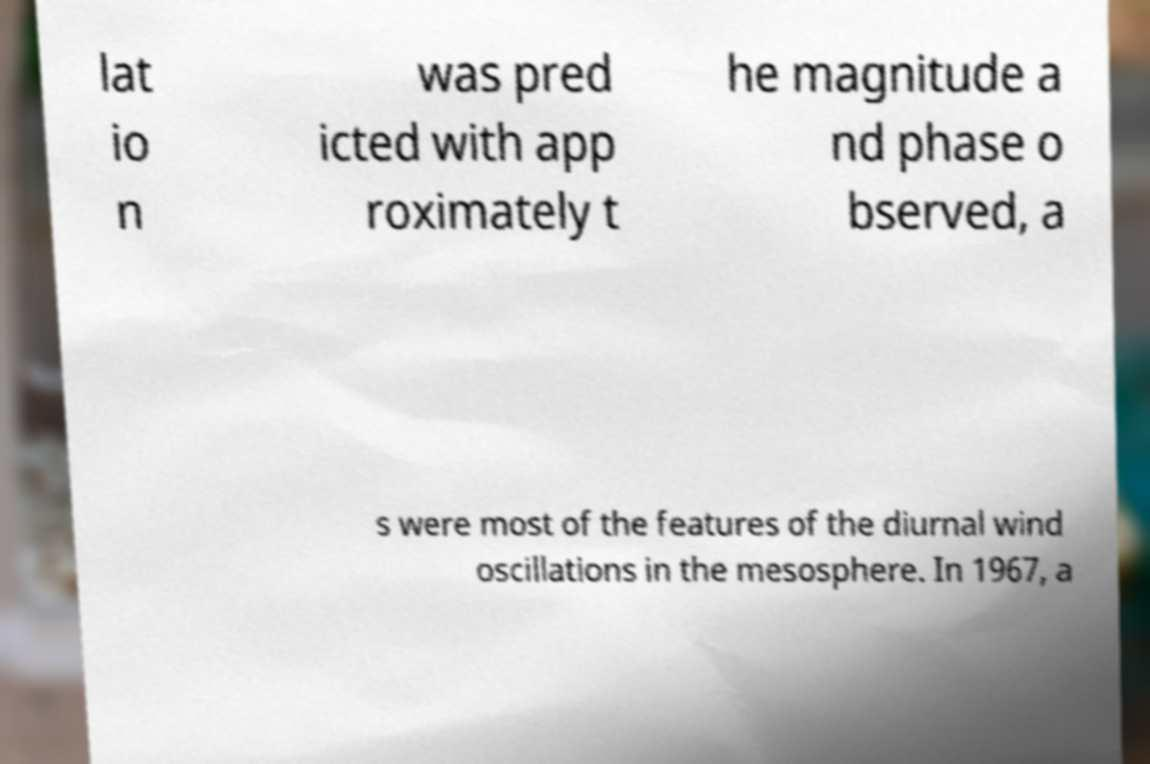For documentation purposes, I need the text within this image transcribed. Could you provide that? lat io n was pred icted with app roximately t he magnitude a nd phase o bserved, a s were most of the features of the diurnal wind oscillations in the mesosphere. In 1967, a 